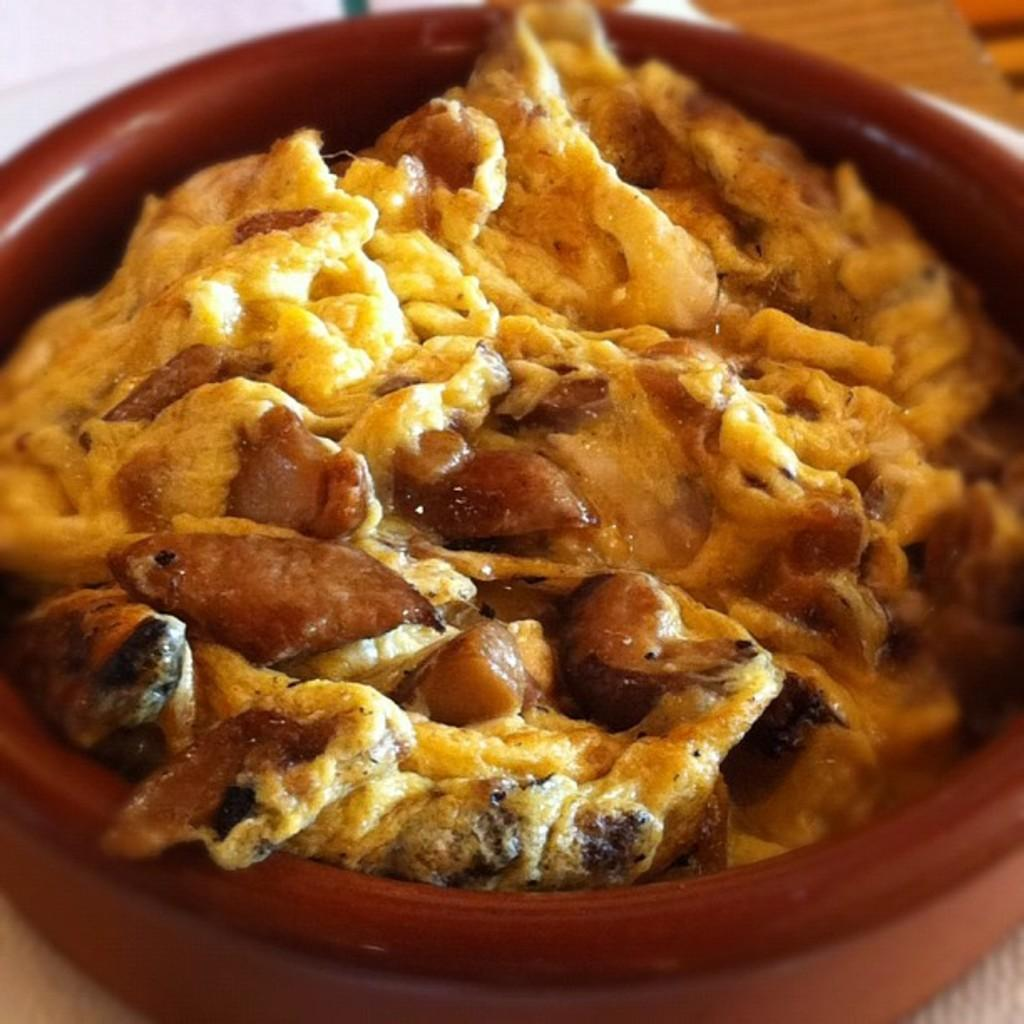What color is the main object in the image? The main object in the image is brown. What can be found inside the brown object? The brown object contains yellow and brown food. How would you describe the overall clarity of the image? The image is slightly blurry in the background. How many horses are visible in the image? There are no horses present in the image. Can you describe the flock of birds in the image? There is no flock of birds present in the image. 